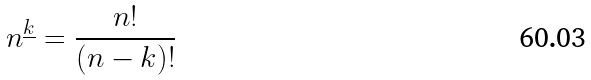Convert formula to latex. <formula><loc_0><loc_0><loc_500><loc_500>n ^ { \underline { k } } = \frac { n ! } { ( n - k ) ! }</formula> 